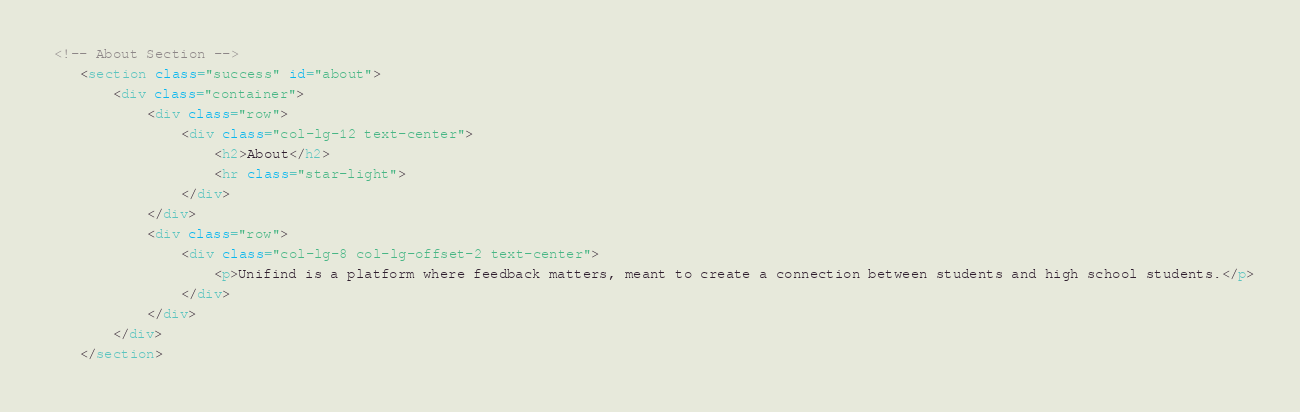Convert code to text. <code><loc_0><loc_0><loc_500><loc_500><_HTML_> <!-- About Section -->
    <section class="success" id="about">
        <div class="container">
            <div class="row">
                <div class="col-lg-12 text-center">
                    <h2>About</h2>
                    <hr class="star-light">
                </div>
            </div>
            <div class="row">
                <div class="col-lg-8 col-lg-offset-2 text-center">
                    <p>Unifind is a platform where feedback matters, meant to create a connection between students and high school students.</p>
                </div>
            </div>
        </div>
    </section>
</code> 